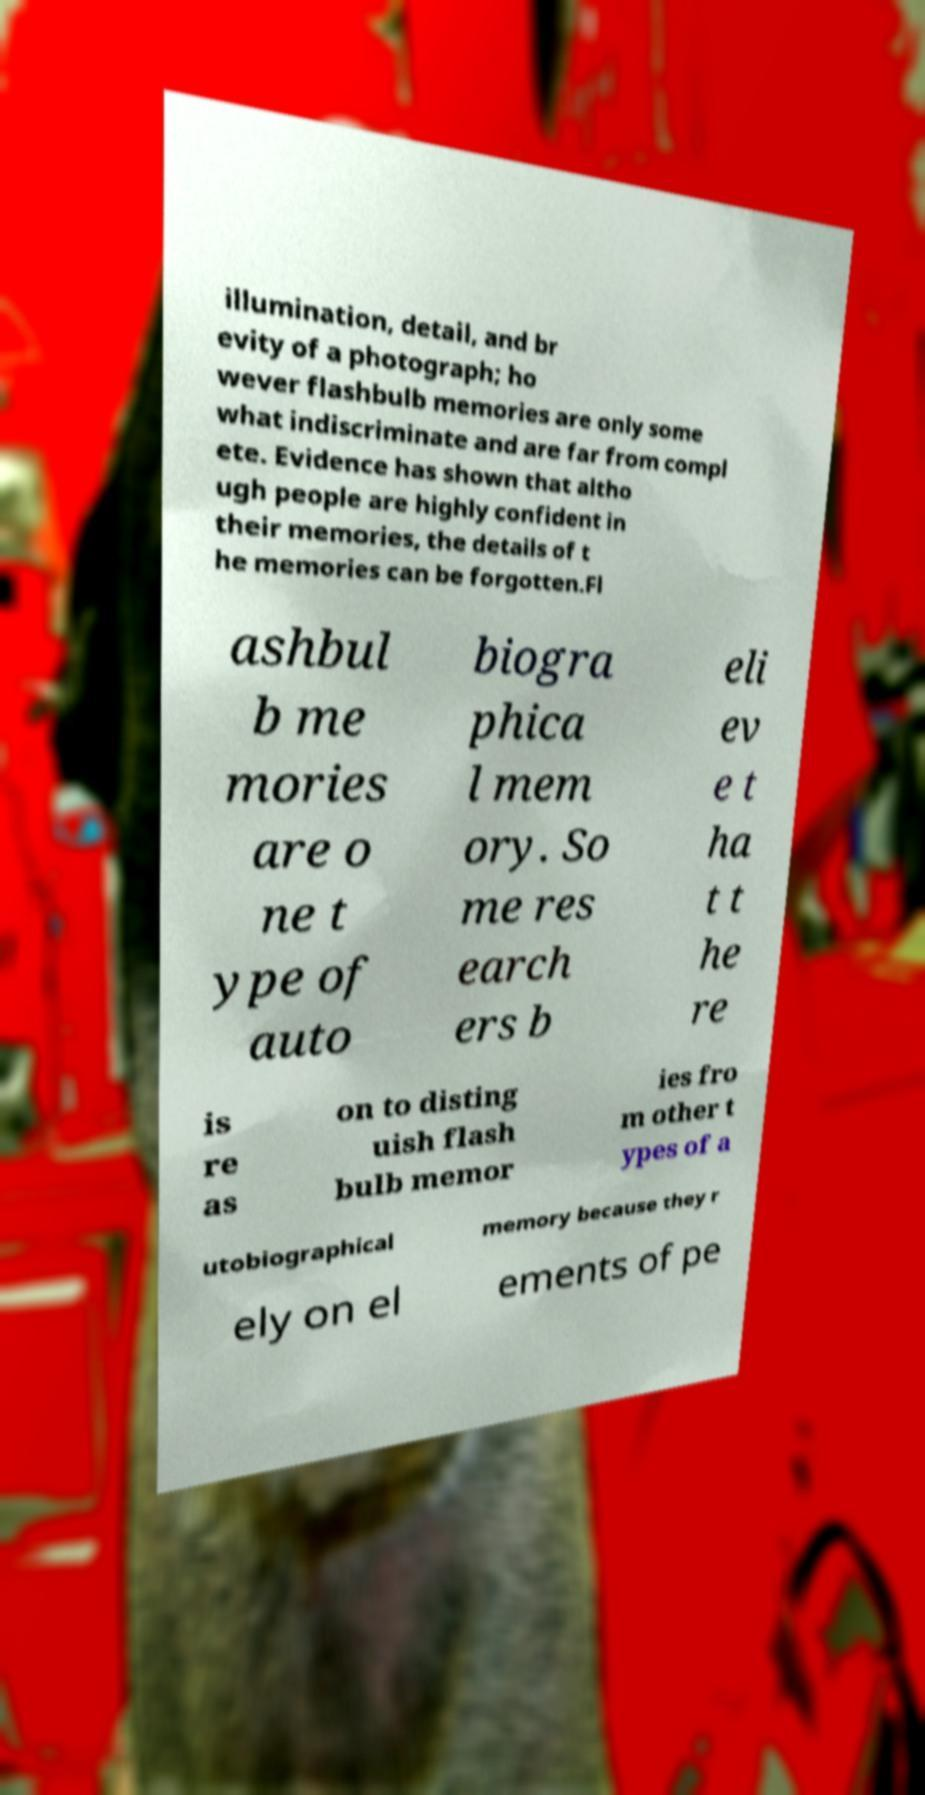Please read and relay the text visible in this image. What does it say? illumination, detail, and br evity of a photograph; ho wever flashbulb memories are only some what indiscriminate and are far from compl ete. Evidence has shown that altho ugh people are highly confident in their memories, the details of t he memories can be forgotten.Fl ashbul b me mories are o ne t ype of auto biogra phica l mem ory. So me res earch ers b eli ev e t ha t t he re is re as on to disting uish flash bulb memor ies fro m other t ypes of a utobiographical memory because they r ely on el ements of pe 